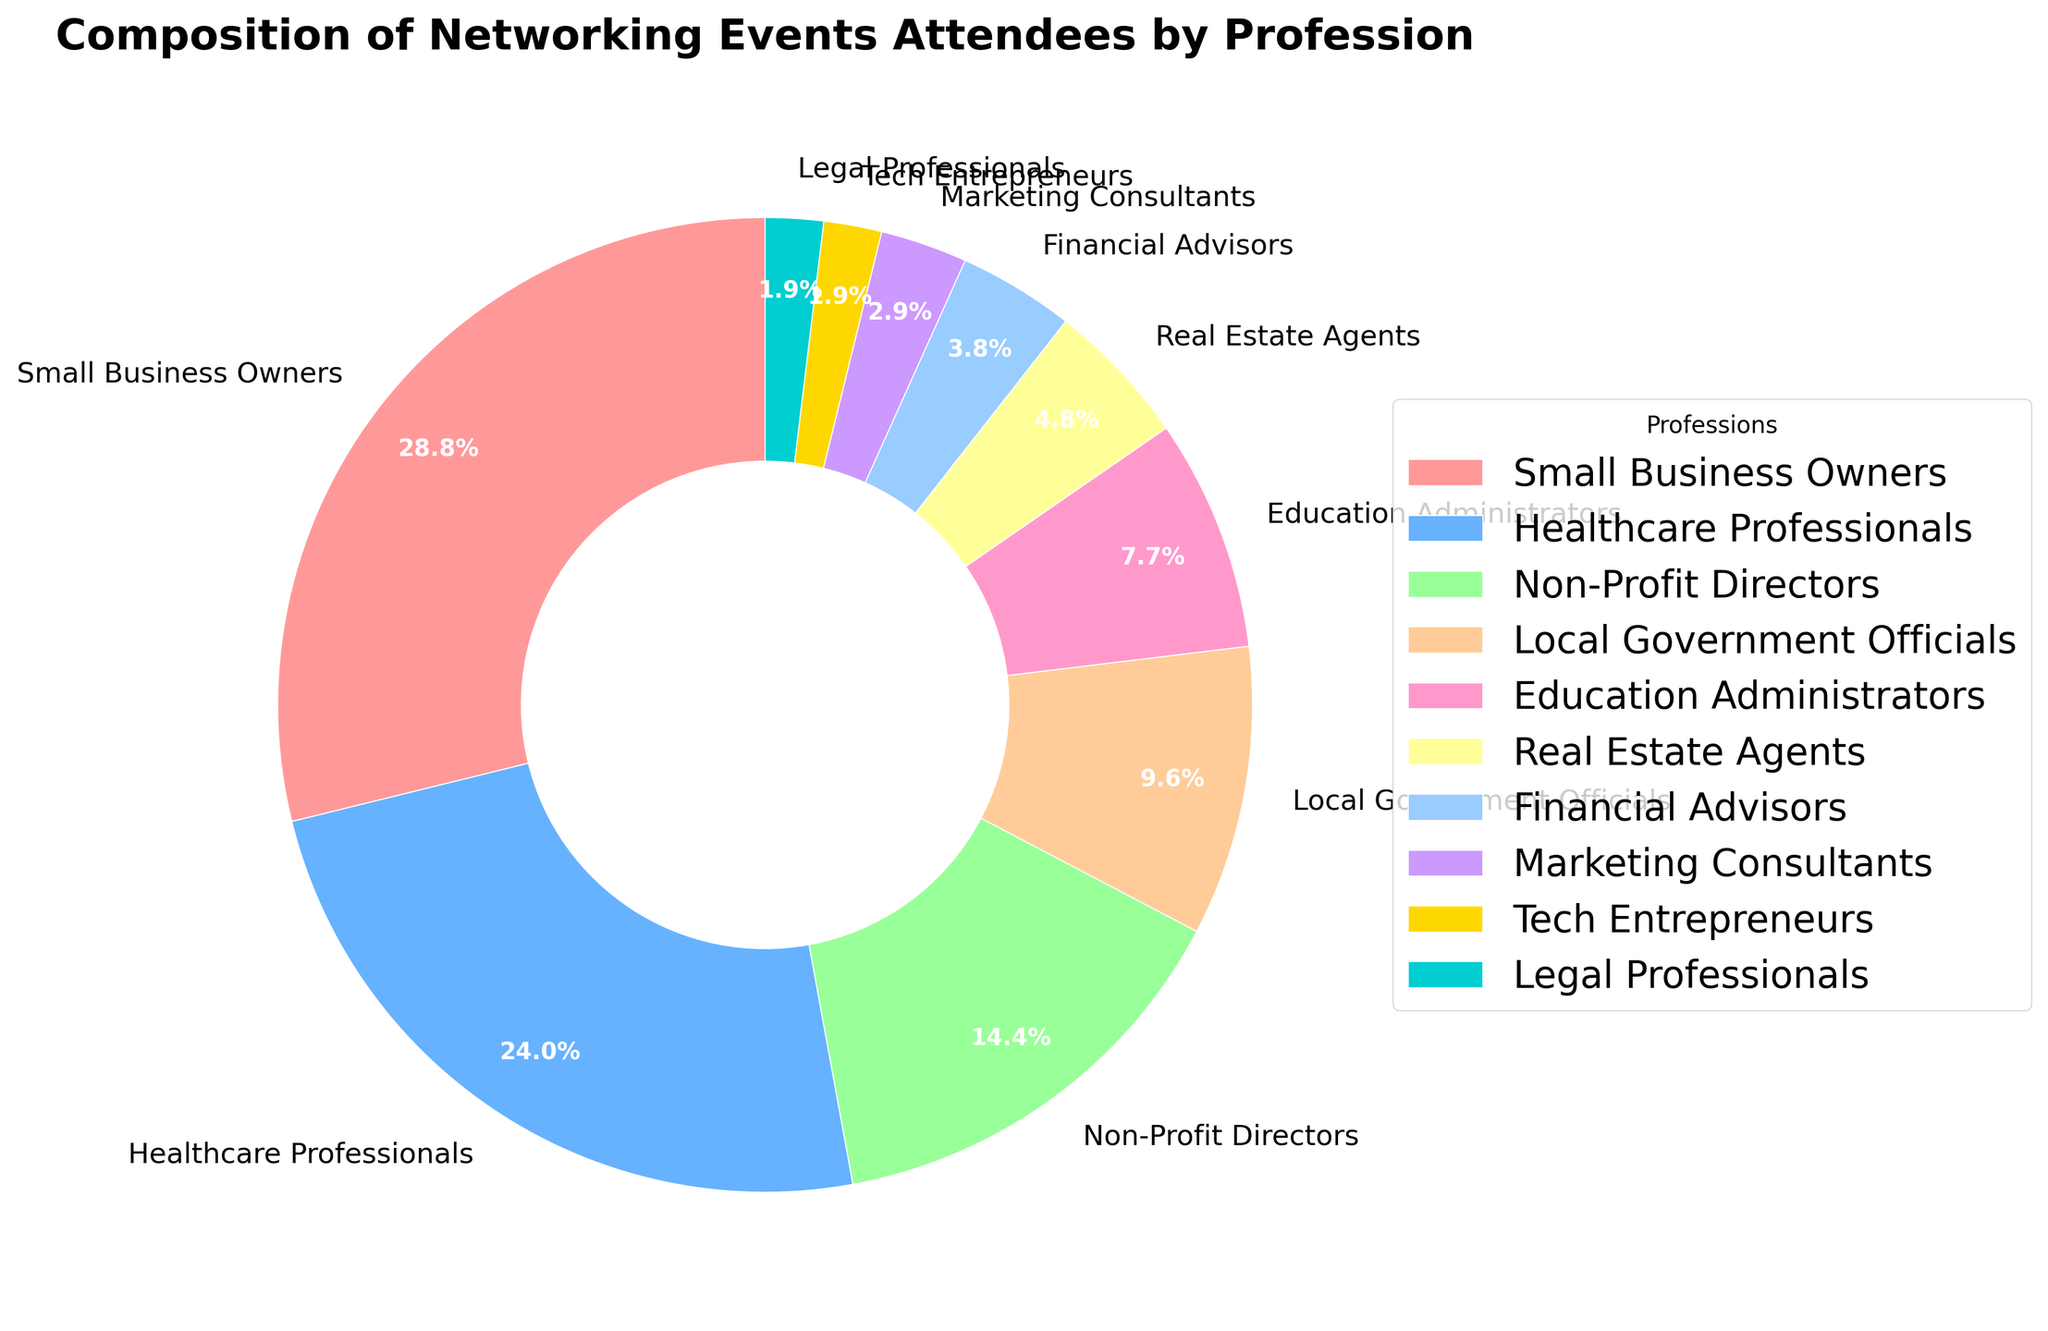Which profession has the highest percentage of attendees at the networking events? The figure shows a pie chart with different percentages for each profession. The slice for "Small Business Owners" is the largest, occupying 30% of the chart. Therefore, "Small Business Owners" have the highest percentage of attendees.
Answer: Small Business Owners What is the total percentage composed by the top three professions? To find the total percentage, identify the top three professions by percentage: Small Business Owners (30%), Healthcare Professionals (25%), and Non-Profit Directors (15%). Add these percentages together: 30% + 25% + 15% = 70%.
Answer: 70% Which professions have the smallest and largest slices, and what are their percentages? The largest slice is for "Small Business Owners" at 30%, and the smallest slices (both equal) are for "Tech Entrepreneurs" and "Legal Professionals" at 2% each, as seen in the pie chart.
Answer: Smallest: Tech Entrepreneurs and Legal Professionals (2%) each, Largest: Small Business Owners (30%) Who has a larger share of attendees: Education Administrators or Financial Advisors? Refer to the pie chart to compare the slices. Education Administrators have 8% and Financial Advisors have 4%. Hence, Education Administrators have a larger share.
Answer: Education Administrators What is the combined percentage of Real Estate Agents, Financial Advisors, Marketing Consultants, Tech Entrepreneurs, and Legal Professionals? Identify and sum the percentages for these professions: Real Estate Agents (5%), Financial Advisors (4%), Marketing Consultants (3%), Tech Entrepreneurs (2%), and Legal Professionals (2%). Calculate the total: 5% + 4% + 3% + 2% + 2% = 16%.
Answer: 16% How much larger is the percentage of Healthcare Professionals compared to Local Government Officials? Healthcare Professionals have a percentage of 25%, while Local Government Officials have 10%. Subtract the smaller percentage from the larger: 25% - 10% = 15%.
Answer: 15% In terms of attendee composition, which professions together make up exactly half of the total attendance? Consider the percentages in descending order. The sum of Small Business Owners (30%) and Healthcare Professionals (25%) is 55%, which exceeds half. Checking Small Business Owners (30%), Healthcare Professionals (25%), and Non-Profit Directors (15%) together gives 30% + 25% + 15% = 70%, also exceeding half. Checking Small Business Owners (30%) and Non-Profit Directors (15%) gives 30% + 15% = 45%, which is less. So, the combination should include Small Business Owners and Healthcare Professionals (30% + 25% = 55%), which exceeds half when verified.
Answer: Small Business Owners and Healthcare Professionals What percentage of attendees are not Small Business Owners or Healthcare Professionals? Sum the percentages of all other professions, excluding Small Business Owners (30%) and Healthcare Professionals (25%). Then subtract this sum from 100%: 100% - (30% + 25%) = 45%.
Answer: 45% If you combine Education Administrators and Local Government Officials, how does their combined percentage compare to that of Non-Profit Directors? Education Administrators have 8% and Local Government Officials have 10%. Combining these gives 8% + 10% = 18%. Non-Profit Directors have 15%. Thus, the combined percentage of Education Administrators and Local Government Officials (18%) is higher than that of Non-Profit Directors (15%).
Answer: 18% is greater than 15% 